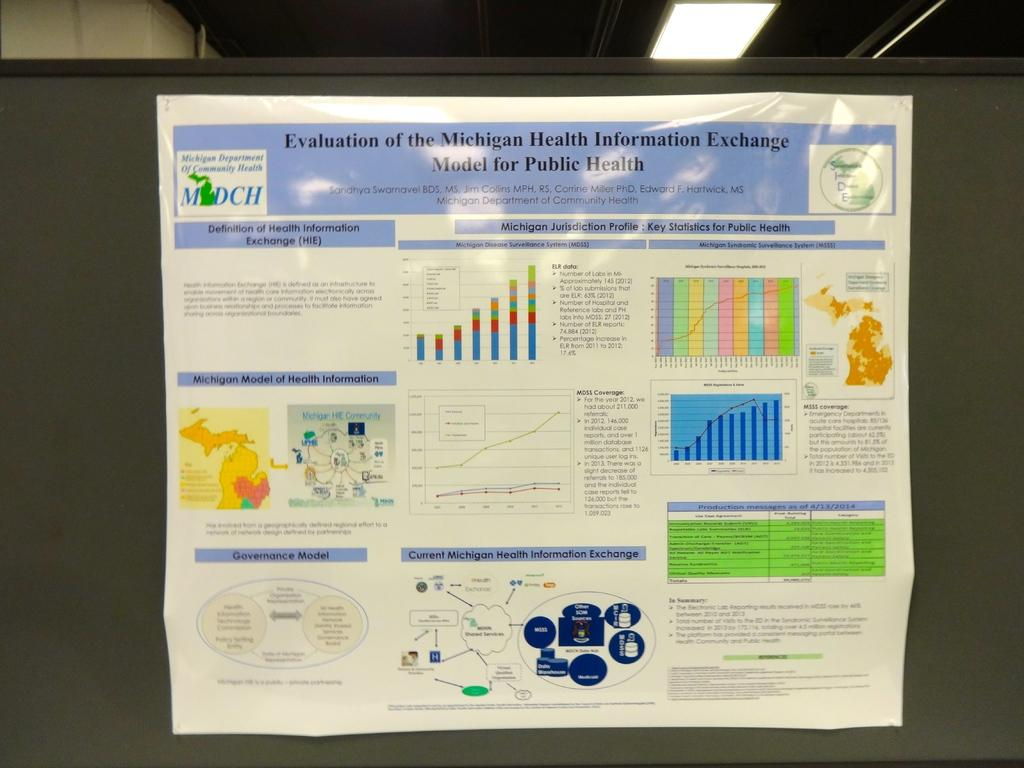Provide a one-sentence caption for the provided image. A poster of the Michigan health information exchange. 